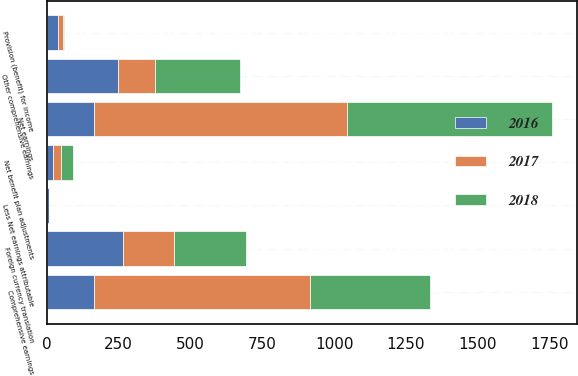Convert chart to OTSL. <chart><loc_0><loc_0><loc_500><loc_500><stacked_bar_chart><ecel><fcel>Net earnings<fcel>Foreign currency translation<fcel>Net benefit plan adjustments<fcel>Other comprehensive earnings<fcel>Provision (benefit) for income<fcel>Comprehensive earnings<fcel>Less Net earnings attributable<nl><fcel>2017<fcel>883.9<fcel>176.6<fcel>29.3<fcel>129.4<fcel>17.9<fcel>754.5<fcel>0.2<nl><fcel>2016<fcel>161.95<fcel>265.1<fcel>20.9<fcel>248.2<fcel>37.8<fcel>161.95<fcel>5.8<nl><fcel>2018<fcel>712.9<fcel>250.8<fcel>40.3<fcel>294.9<fcel>3.8<fcel>418<fcel>1.1<nl></chart> 